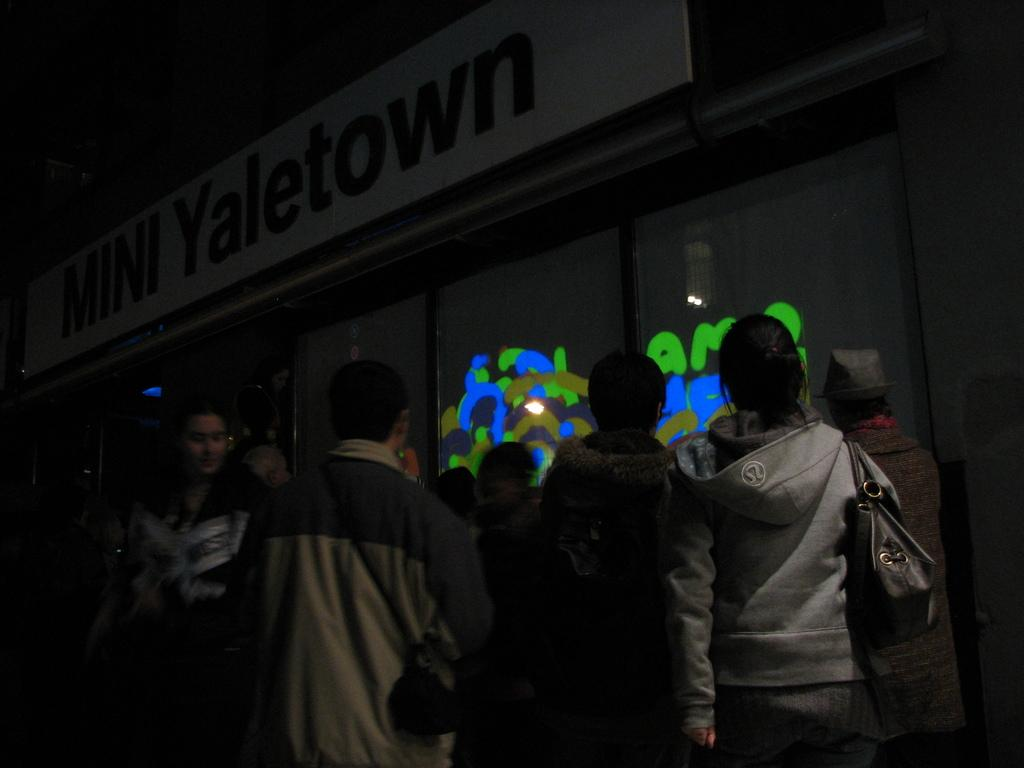What is happening at the bottom of the image? There is a group of people at the bottom of the image. What can be seen in the background of the image? There is a building in the background of the image. Can you describe the lighting in the top left corner of the image? The top left corner of the image is dark. What type of detail can be seen on the grip of the building in the image? There is no mention of a grip or any specific detail on the building in the provided facts, so it cannot be determined from the image. 